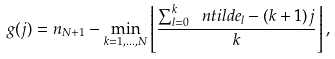<formula> <loc_0><loc_0><loc_500><loc_500>g ( j ) = n _ { N + 1 } - \min _ { k = 1 , \dots , N } \left \lfloor \frac { \sum _ { l = 0 } ^ { k } \ n t i l d e _ { l } - ( k + 1 ) j } { k } \right \rfloor ,</formula> 